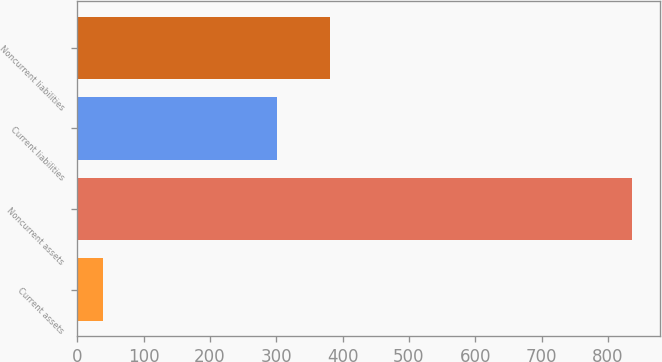Convert chart. <chart><loc_0><loc_0><loc_500><loc_500><bar_chart><fcel>Current assets<fcel>Noncurrent assets<fcel>Current liabilities<fcel>Noncurrent liabilities<nl><fcel>38<fcel>836<fcel>301<fcel>380.8<nl></chart> 